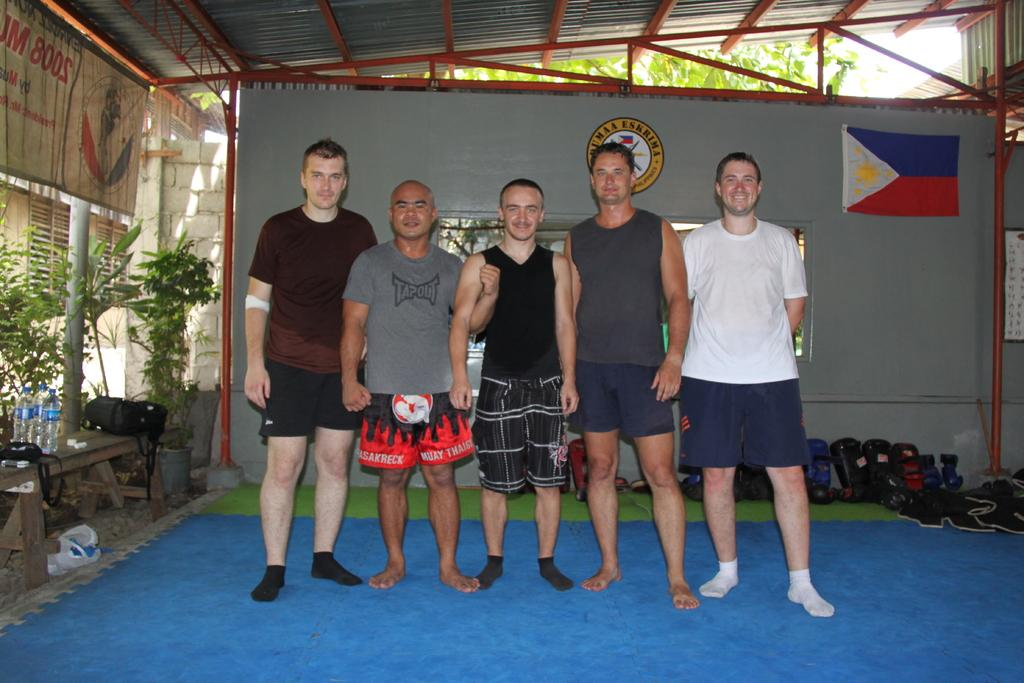<image>
Describe the image concisely. a few men with one that has fire shorts that says muay on them 